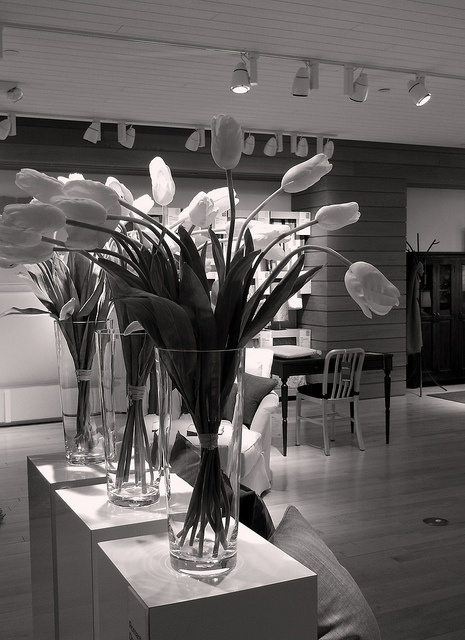Describe the objects in this image and their specific colors. I can see vase in gray, black, darkgray, and lightgray tones, vase in gray, black, darkgray, and lightgray tones, vase in gray, darkgray, and black tones, chair in gray, darkgray, lightgray, and black tones, and chair in gray and black tones in this image. 